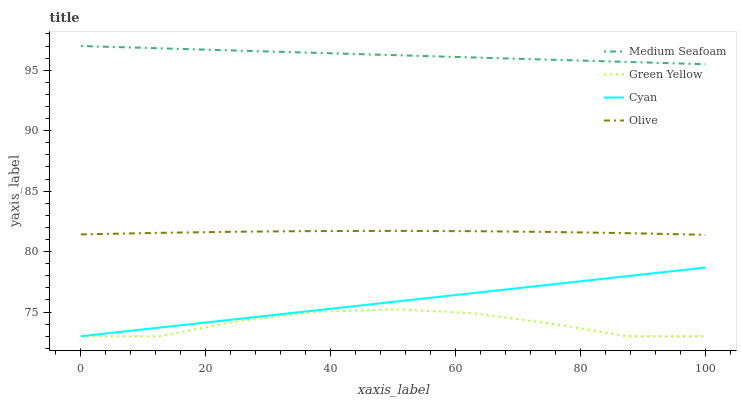Does Green Yellow have the minimum area under the curve?
Answer yes or no. Yes. Does Medium Seafoam have the maximum area under the curve?
Answer yes or no. Yes. Does Cyan have the minimum area under the curve?
Answer yes or no. No. Does Cyan have the maximum area under the curve?
Answer yes or no. No. Is Cyan the smoothest?
Answer yes or no. Yes. Is Green Yellow the roughest?
Answer yes or no. Yes. Is Green Yellow the smoothest?
Answer yes or no. No. Is Cyan the roughest?
Answer yes or no. No. Does Medium Seafoam have the lowest value?
Answer yes or no. No. Does Medium Seafoam have the highest value?
Answer yes or no. Yes. Does Cyan have the highest value?
Answer yes or no. No. Is Green Yellow less than Olive?
Answer yes or no. Yes. Is Medium Seafoam greater than Green Yellow?
Answer yes or no. Yes. Does Green Yellow intersect Cyan?
Answer yes or no. Yes. Is Green Yellow less than Cyan?
Answer yes or no. No. Is Green Yellow greater than Cyan?
Answer yes or no. No. Does Green Yellow intersect Olive?
Answer yes or no. No. 